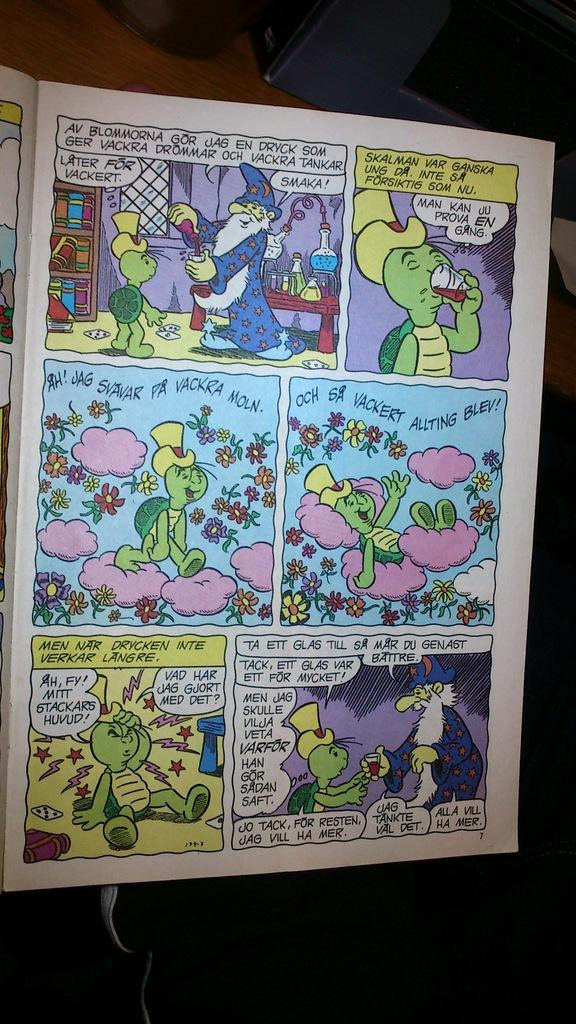<image>
Create a compact narrative representing the image presented. A cartoon book that is opened to page 7. 